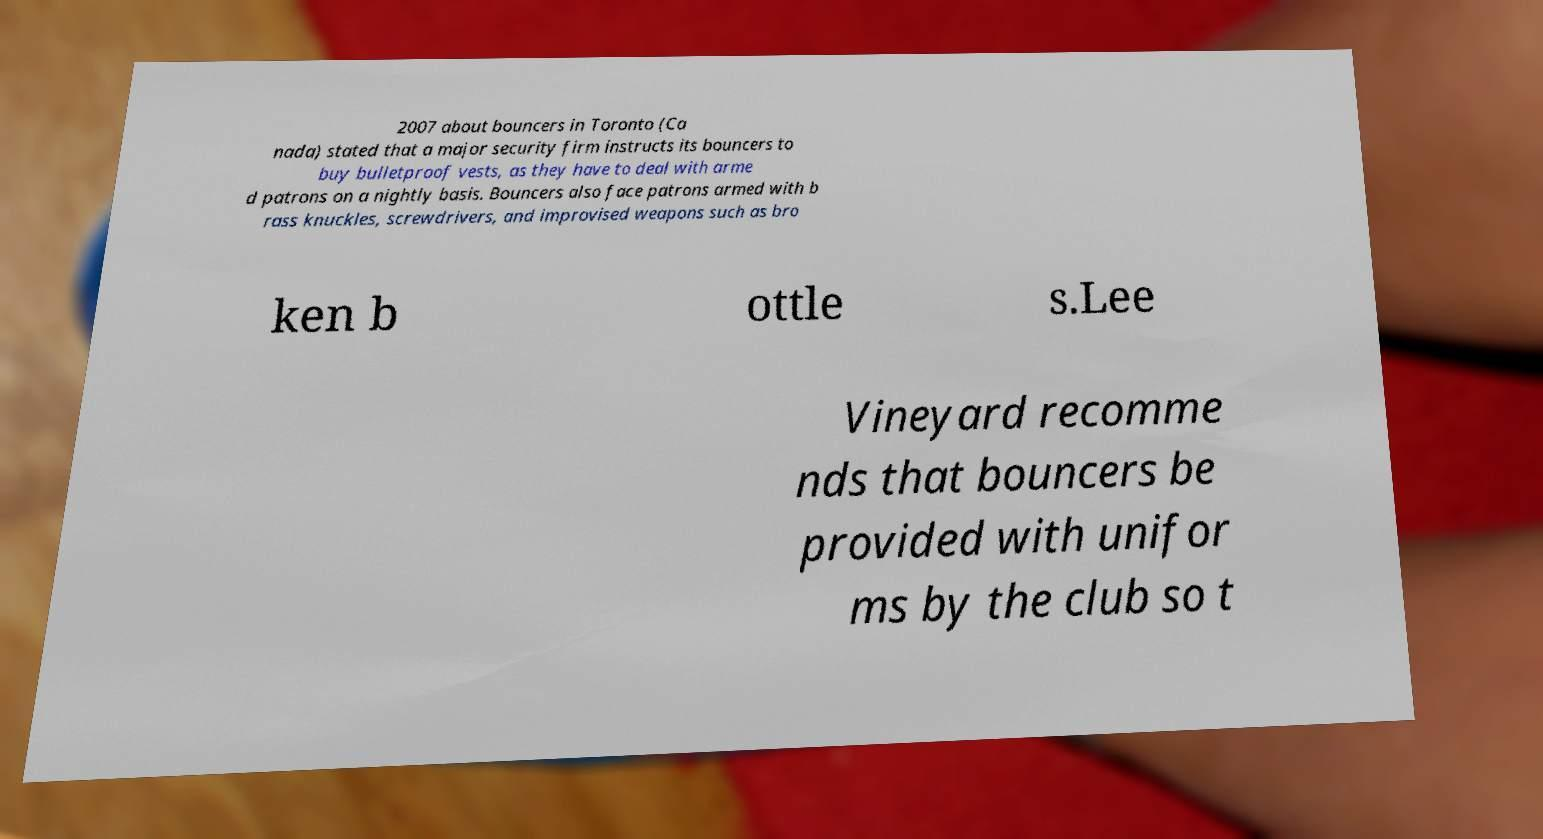Can you accurately transcribe the text from the provided image for me? 2007 about bouncers in Toronto (Ca nada) stated that a major security firm instructs its bouncers to buy bulletproof vests, as they have to deal with arme d patrons on a nightly basis. Bouncers also face patrons armed with b rass knuckles, screwdrivers, and improvised weapons such as bro ken b ottle s.Lee Vineyard recomme nds that bouncers be provided with unifor ms by the club so t 